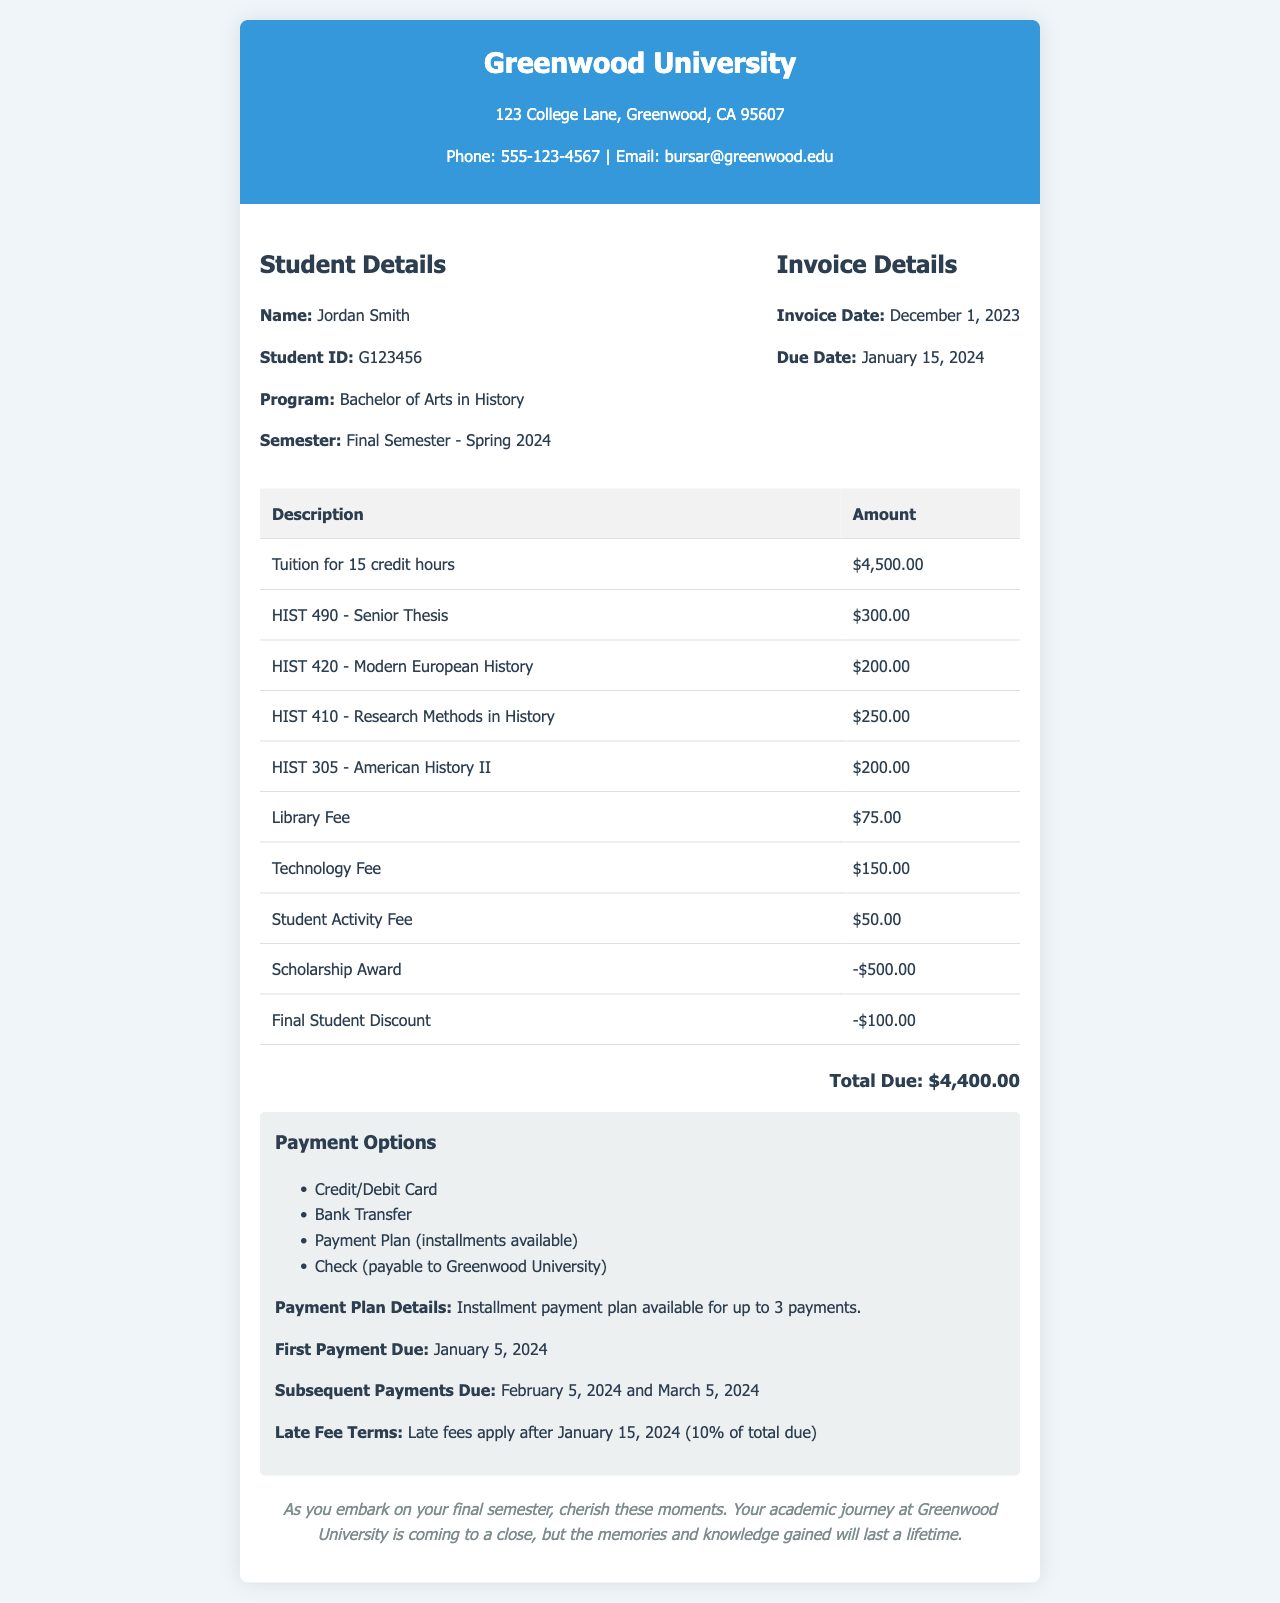What is the student's name? The document provides the name of the student in the student info section.
Answer: Jordan Smith What is the total amount due? The total amount due is highlighted in the total section of the invoice.
Answer: $4,400.00 When is the due date for the invoice? The due date is listed in the invoice details section.
Answer: January 15, 2024 What course has the highest charge? The highest charge can be found by comparing the amounts listed under course-specific charges.
Answer: $4,500.00 (Tuition for 15 credit hours) What are the payment methods available? The payment options section lists available payment methods.
Answer: Credit/Debit Card, Bank Transfer, Payment Plan, Check How much is the scholarship award? The scholarship award amount is specified in the line item on the invoice.
Answer: -$500.00 How many courses are listed in the invoice? The total number of courses can be counted from the course-specific charges in the table.
Answer: 4 What is the first payment due date if using a payment plan? The first payment due date is provided in the payment options section.
Answer: January 5, 2024 What is the late fee percentage applicable after the due date? The late fee terms section outlines the percentage charged after the due date.
Answer: 10% 